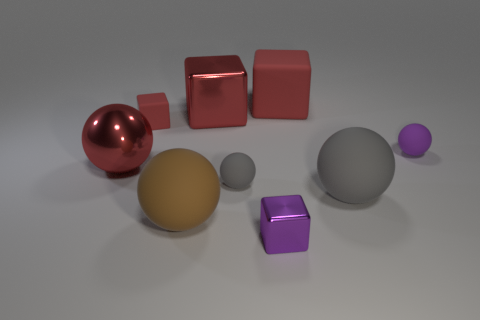Subtract all red cubes. How many were subtracted if there are1red cubes left? 2 Subtract all purple cubes. How many cubes are left? 3 Subtract all cyan spheres. How many red blocks are left? 3 Add 1 large matte blocks. How many objects exist? 10 Subtract all red balls. How many balls are left? 4 Subtract 2 cubes. How many cubes are left? 2 Subtract all blocks. How many objects are left? 5 Add 4 tiny purple shiny objects. How many tiny purple shiny objects exist? 5 Subtract 0 gray cubes. How many objects are left? 9 Subtract all brown cubes. Subtract all purple spheres. How many cubes are left? 4 